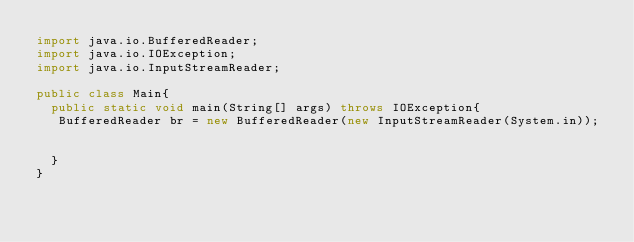<code> <loc_0><loc_0><loc_500><loc_500><_Java_>import java.io.BufferedReader;
import java.io.IOException;
import java.io.InputStreamReader;

public class Main{
  public static void main(String[] args) throws IOException{
   BufferedReader br = new BufferedReader(new InputStreamReader(System.in));
   

  }
}</code> 